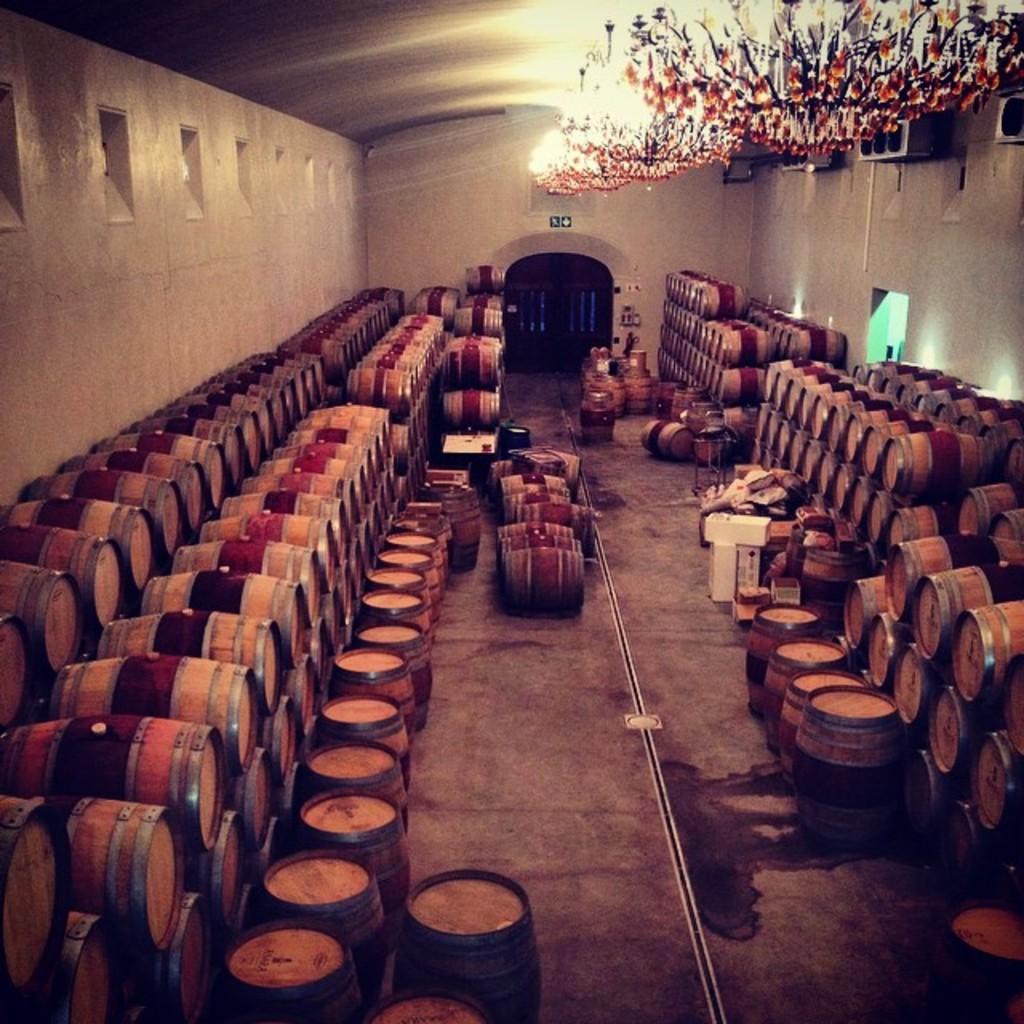How would you summarize this image in a sentence or two? This picture shows wooden barrels in a row and we see few lights on the roof 